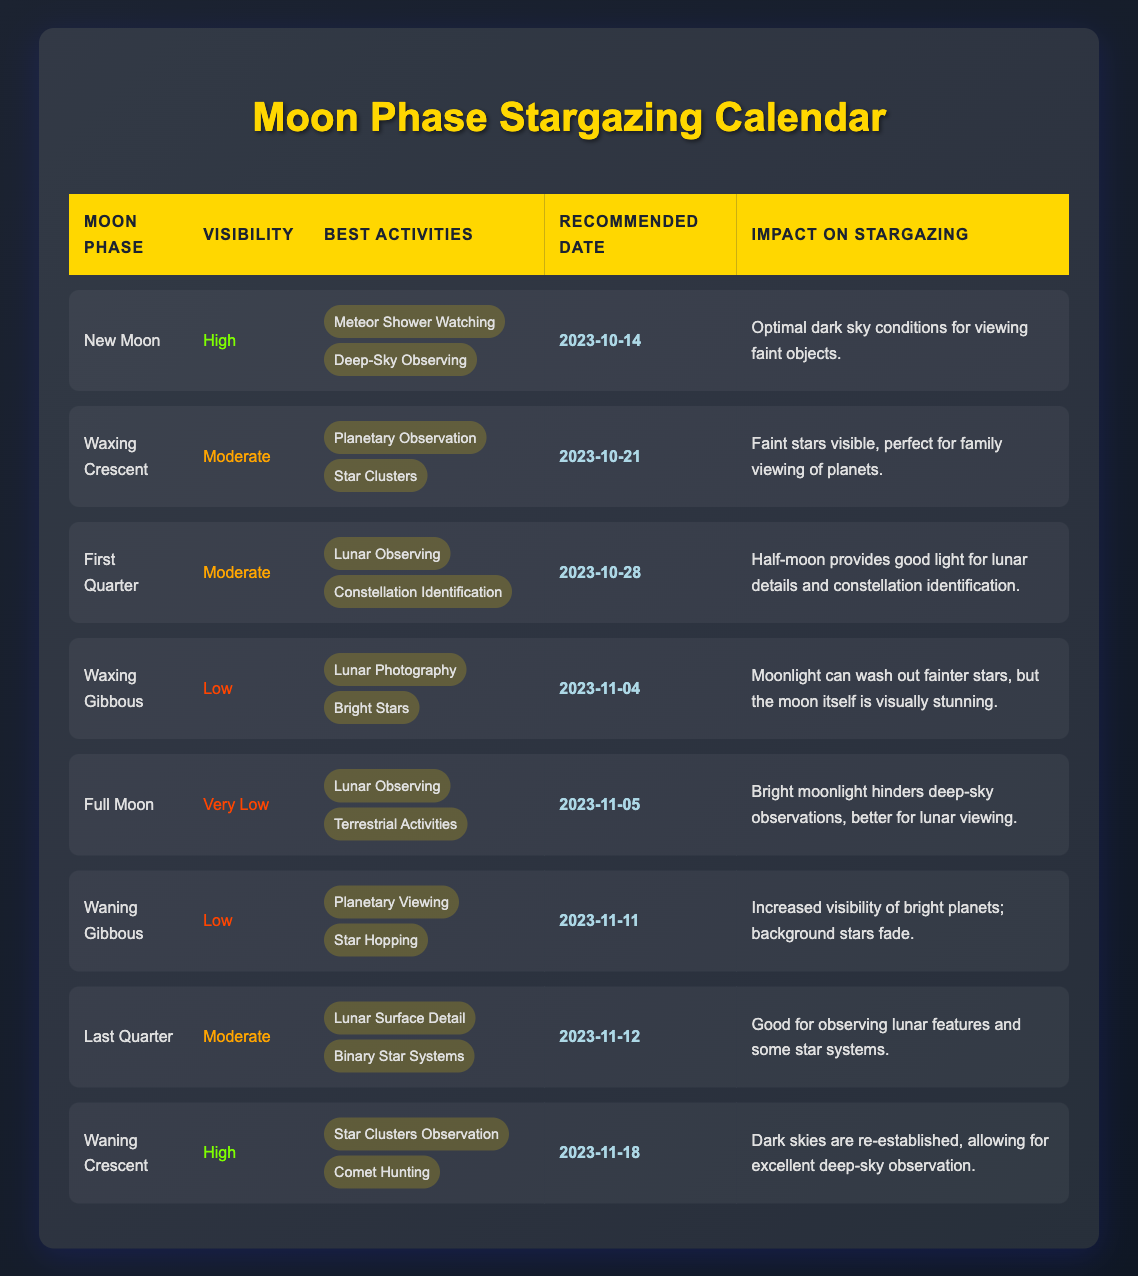What are the best activities for the New Moon phase? Referring to the best activities listed under the New Moon phase in the table, they are "Meteor Shower Watching" and "Deep-Sky Observing."
Answer: Meteor Shower Watching, Deep-Sky Observing On which date is the Waxing Gibbous phase set to occur? By looking at the recommended date column for the Waxing Gibbous phase, it is stated as "2023-11-04."
Answer: 2023-11-04 Is observing star clusters recommended during the Full Moon phase? The best activities listed for the Full Moon phase do not include star clusters; they are focused on lunar observing and terrestrial activities. Hence, it is not recommended.
Answer: No What is the impact on stargazing during the Waning Crescent phase? The impact on stargazing for the Waning Crescent phase states, "Dark skies are re-established, allowing for excellent deep-sky observation."
Answer: Excellent deep-sky observation Which Moon phase has the highest visibility rating? By observing the visibility ratings in the table, both the New Moon and Waning Crescent phases have a visibility rating of "High."
Answer: New Moon, Waning Crescent What activities are recommended for the Last Quarter phase? The table lists "Lunar Surface Detail" and "Binary Star Systems" as the best activities for the Last Quarter phase.
Answer: Lunar Surface Detail, Binary Star Systems How many phases have a visibility rating of "Low"? The table shows that the Waxing Gibbous and Waning Gibbous phases have a visibility rating of "Low," making a total of two phases with that rating.
Answer: 2 What is the difference in visibility between the New Moon and Full Moon phases? The New Moon phase has a visibility rating of "High," while the Full Moon phase is rated "Very Low." This indicates a difference of three categories.
Answer: Three categories difference Which Moon phase is most suitable for observing faint objects? According to the data, the New Moon phase is the most suitable due to "Optimal dark sky conditions for viewing faint objects."
Answer: New Moon 